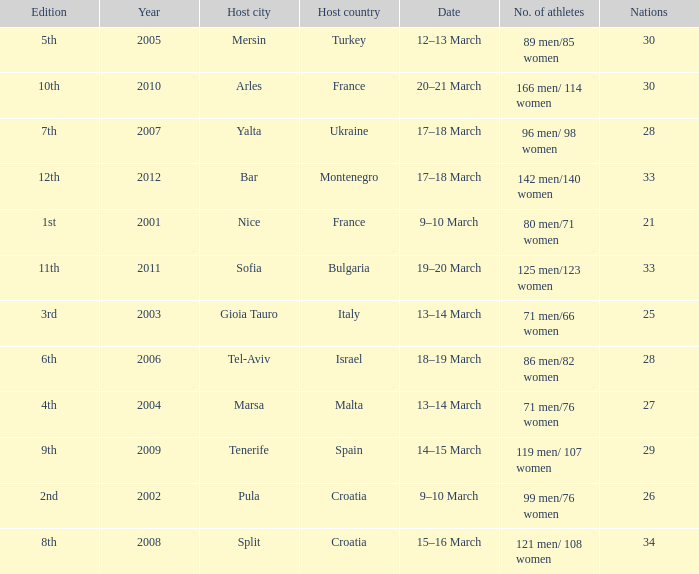What was the number of athletes for the 7th edition? 96 men/ 98 women. 